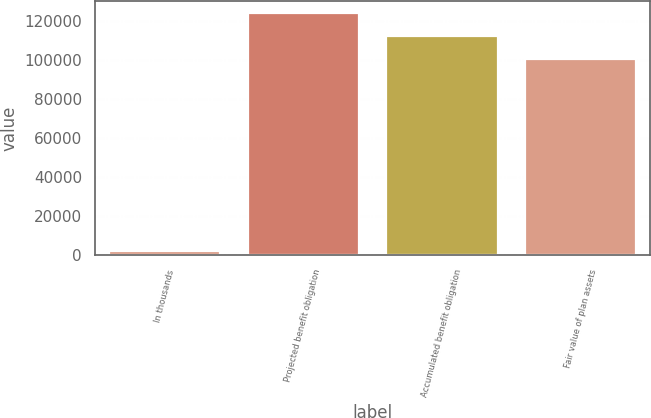<chart> <loc_0><loc_0><loc_500><loc_500><bar_chart><fcel>In thousands<fcel>Projected benefit obligation<fcel>Accumulated benefit obligation<fcel>Fair value of plan assets<nl><fcel>2013<fcel>123939<fcel>112368<fcel>100798<nl></chart> 